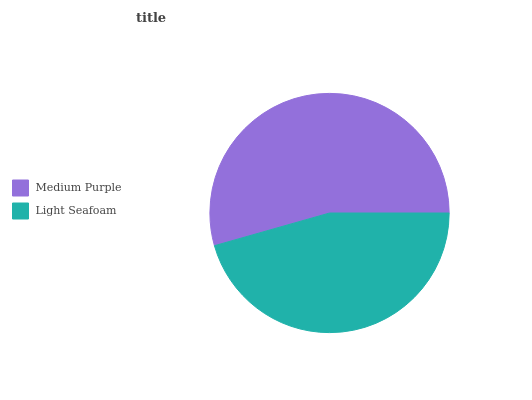Is Light Seafoam the minimum?
Answer yes or no. Yes. Is Medium Purple the maximum?
Answer yes or no. Yes. Is Light Seafoam the maximum?
Answer yes or no. No. Is Medium Purple greater than Light Seafoam?
Answer yes or no. Yes. Is Light Seafoam less than Medium Purple?
Answer yes or no. Yes. Is Light Seafoam greater than Medium Purple?
Answer yes or no. No. Is Medium Purple less than Light Seafoam?
Answer yes or no. No. Is Medium Purple the high median?
Answer yes or no. Yes. Is Light Seafoam the low median?
Answer yes or no. Yes. Is Light Seafoam the high median?
Answer yes or no. No. Is Medium Purple the low median?
Answer yes or no. No. 